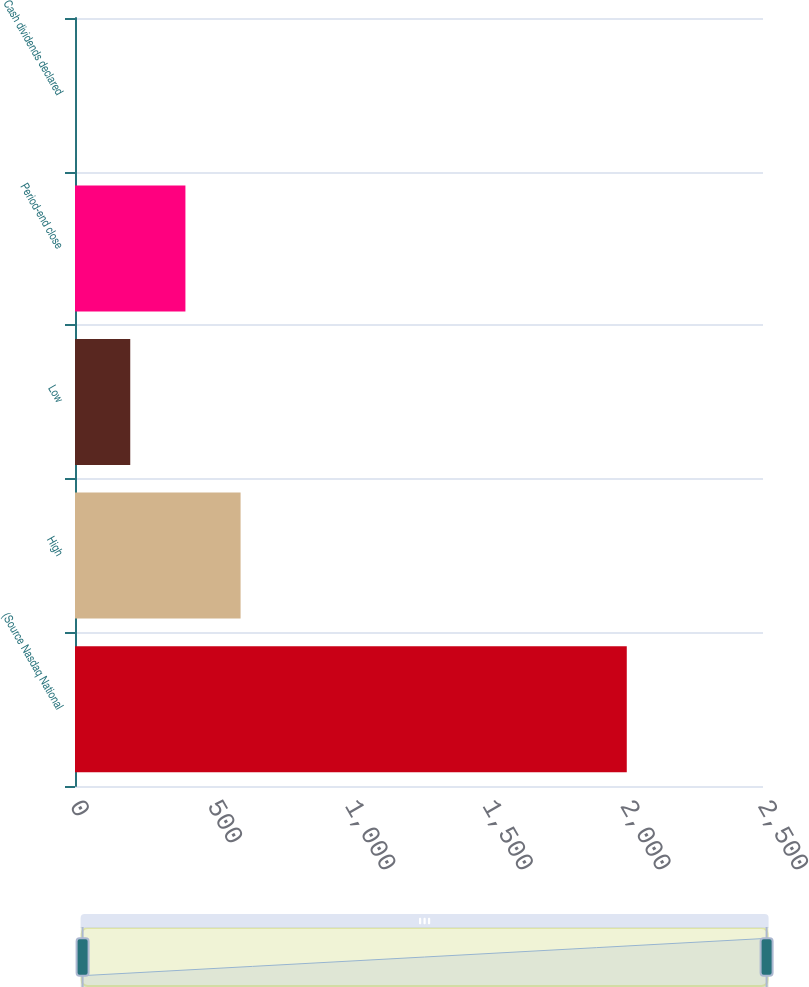Convert chart. <chart><loc_0><loc_0><loc_500><loc_500><bar_chart><fcel>(Source Nasdaq National<fcel>High<fcel>Low<fcel>Period-end close<fcel>Cash dividends declared<nl><fcel>2005<fcel>601.7<fcel>200.76<fcel>401.23<fcel>0.29<nl></chart> 